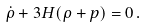<formula> <loc_0><loc_0><loc_500><loc_500>\dot { \rho } + 3 H ( \rho + p ) = 0 \, .</formula> 